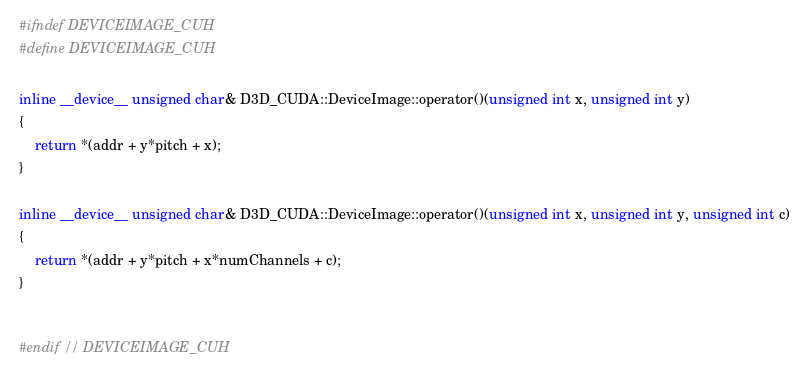Convert code to text. <code><loc_0><loc_0><loc_500><loc_500><_Cuda_>#ifndef DEVICEIMAGE_CUH
#define DEVICEIMAGE_CUH

inline __device__ unsigned char& D3D_CUDA::DeviceImage::operator()(unsigned int x, unsigned int y)
{
    return *(addr + y*pitch + x);
}

inline __device__ unsigned char& D3D_CUDA::DeviceImage::operator()(unsigned int x, unsigned int y, unsigned int c)
{
    return *(addr + y*pitch + x*numChannels + c);
}


#endif // DEVICEIMAGE_CUH
</code> 